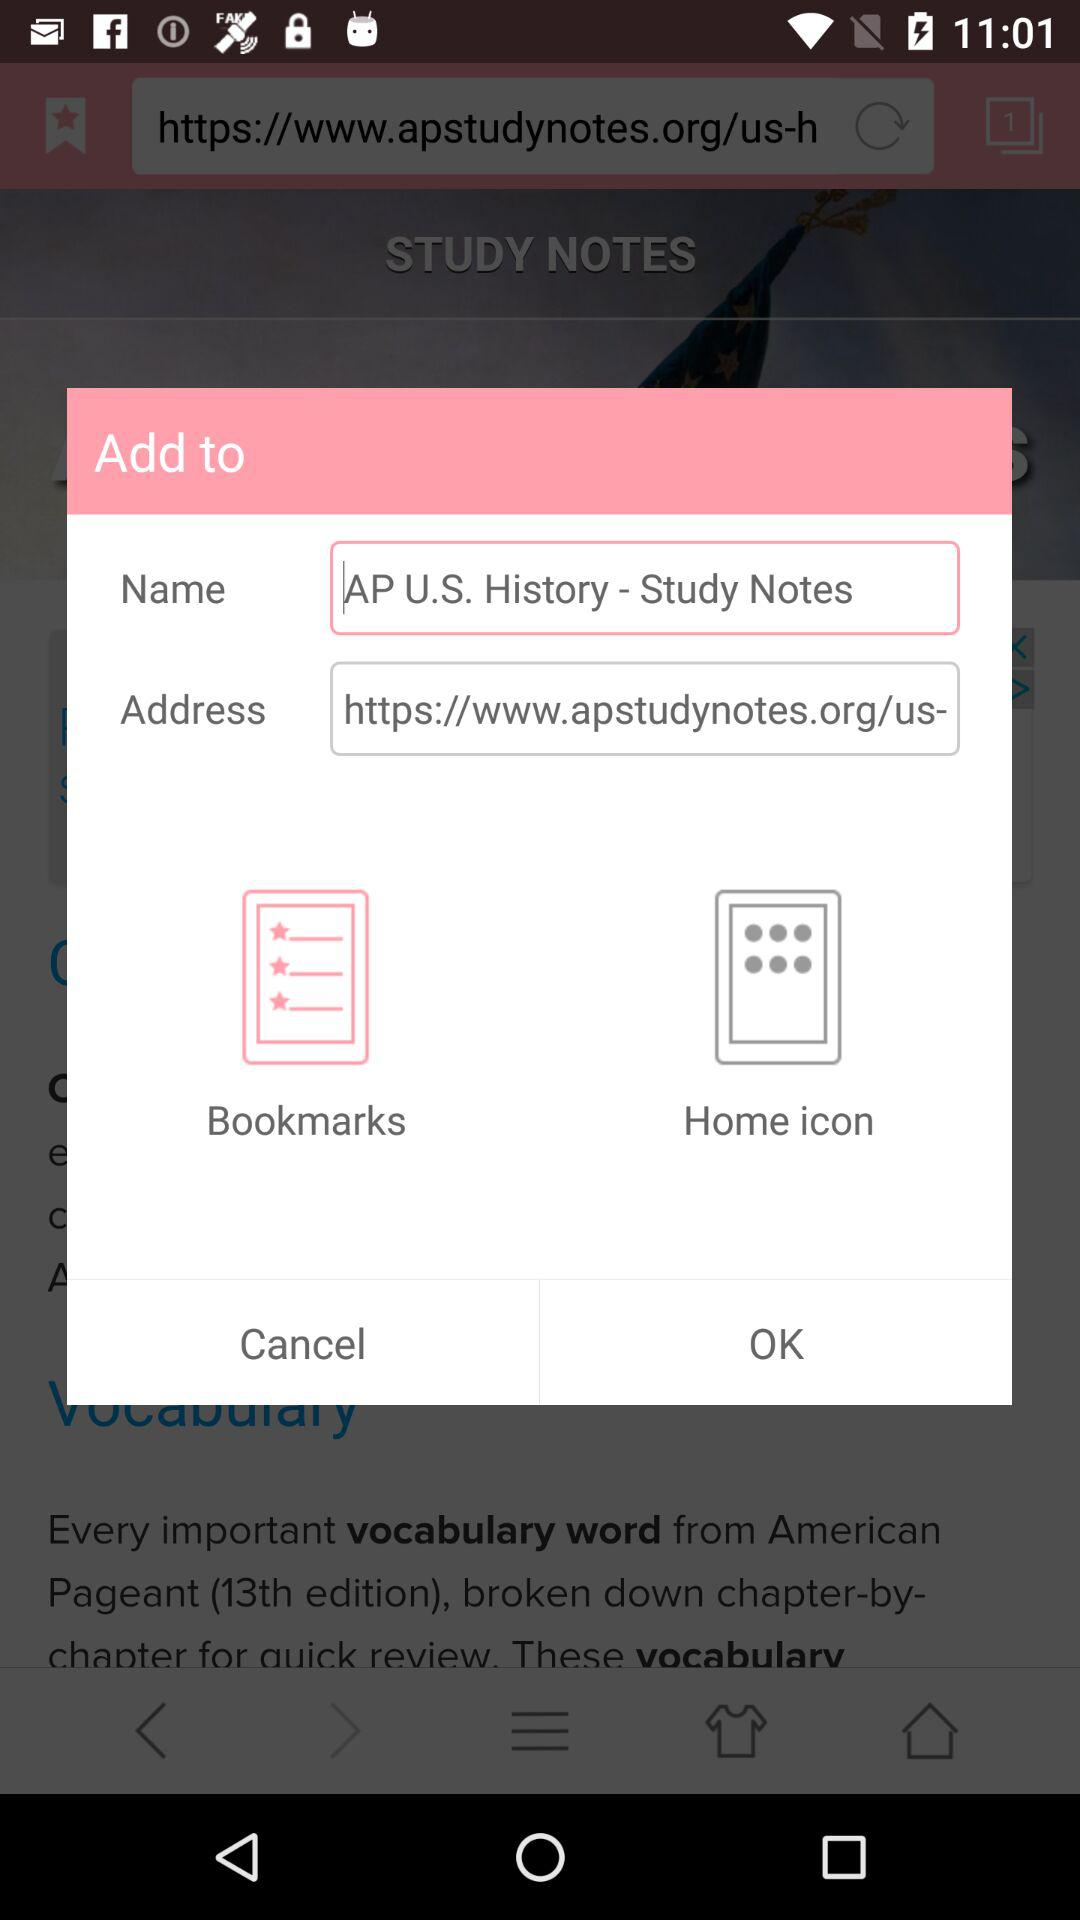What's the name? The name is AP U.S. History - Study Notes. 